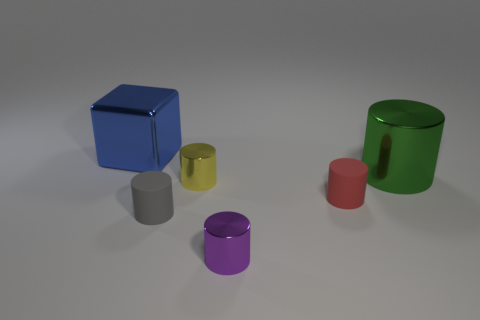Are there the same number of purple metal objects that are behind the blue block and purple metal objects?
Make the answer very short. No. There is a object that is both behind the yellow thing and on the left side of the purple thing; how big is it?
Make the answer very short. Large. The object that is behind the large shiny thing that is to the right of the blue metal object is what color?
Your response must be concise. Blue. How many purple objects are either big metallic cylinders or tiny cylinders?
Make the answer very short. 1. There is a shiny thing that is both on the left side of the tiny purple object and to the right of the gray matte thing; what is its color?
Provide a succinct answer. Yellow. How many big things are either brown metallic things or yellow metallic things?
Offer a terse response. 0. There is a green shiny object that is the same shape as the small red thing; what is its size?
Offer a very short reply. Large. What is the shape of the blue thing?
Your answer should be compact. Cube. Is the material of the large blue thing the same as the small red cylinder in front of the large metal cylinder?
Your response must be concise. No. How many rubber objects are either gray things or tiny cylinders?
Offer a terse response. 2. 